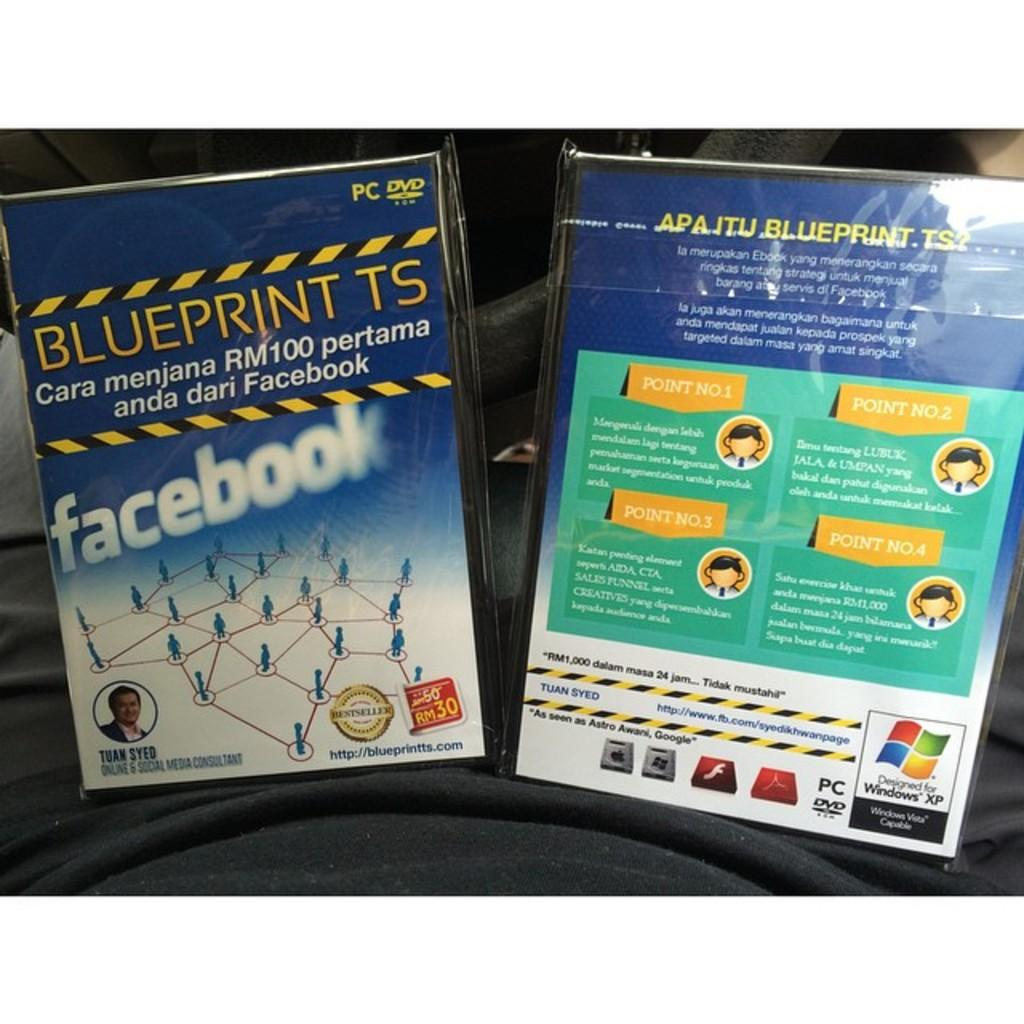Provide a one-sentence caption for the provided image. A DVD for Blueprint TS was created by Tuan Syed, an online and social media consultant. 